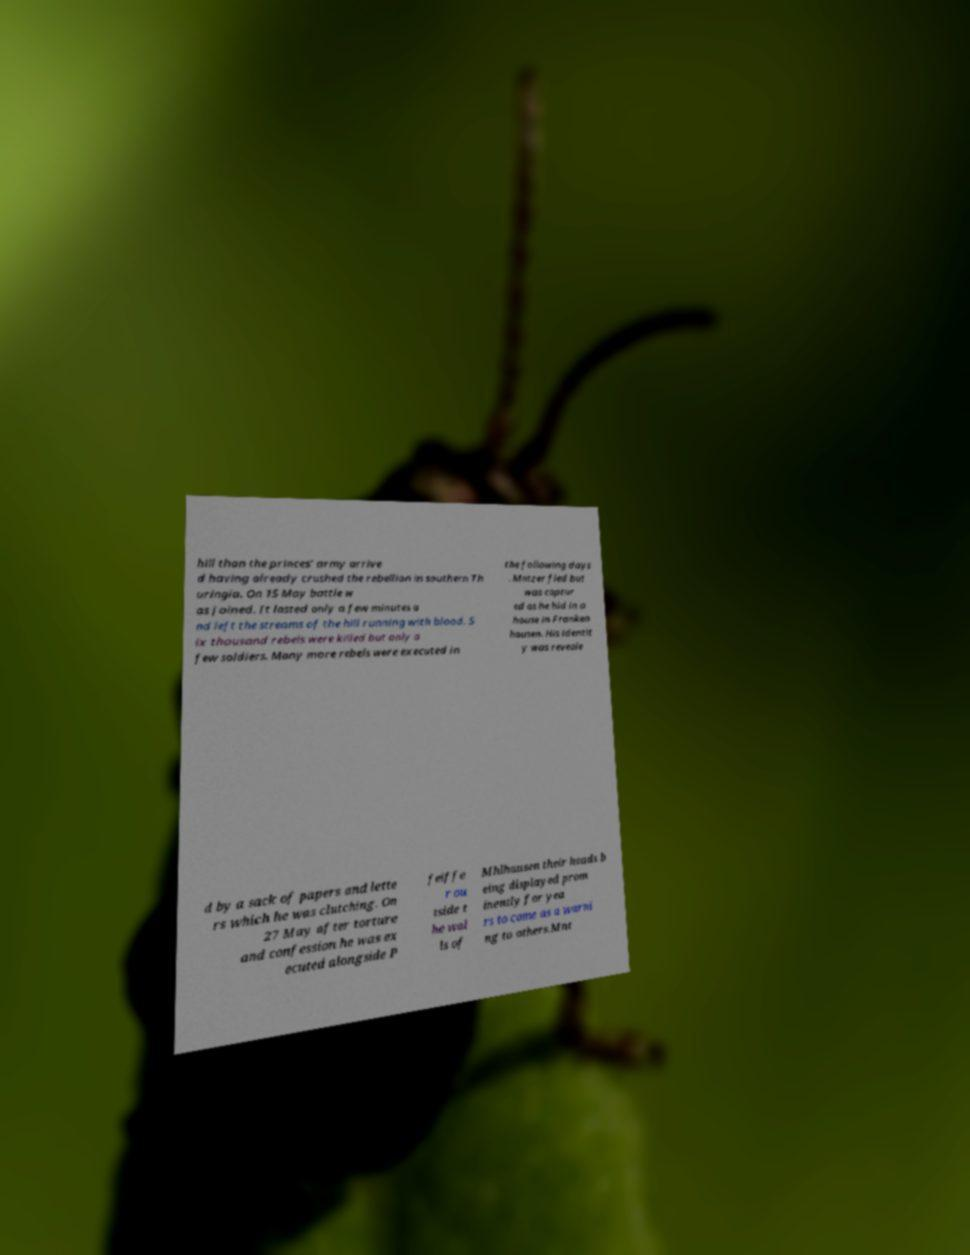For documentation purposes, I need the text within this image transcribed. Could you provide that? hill than the princes’ army arrive d having already crushed the rebellion in southern Th uringia. On 15 May battle w as joined. It lasted only a few minutes a nd left the streams of the hill running with blood. S ix thousand rebels were killed but only a few soldiers. Many more rebels were executed in the following days . Mntzer fled but was captur ed as he hid in a house in Franken hausen. His identit y was reveale d by a sack of papers and lette rs which he was clutching. On 27 May after torture and confession he was ex ecuted alongside P feiffe r ou tside t he wal ls of Mhlhausen their heads b eing displayed prom inently for yea rs to come as a warni ng to others.Mnt 